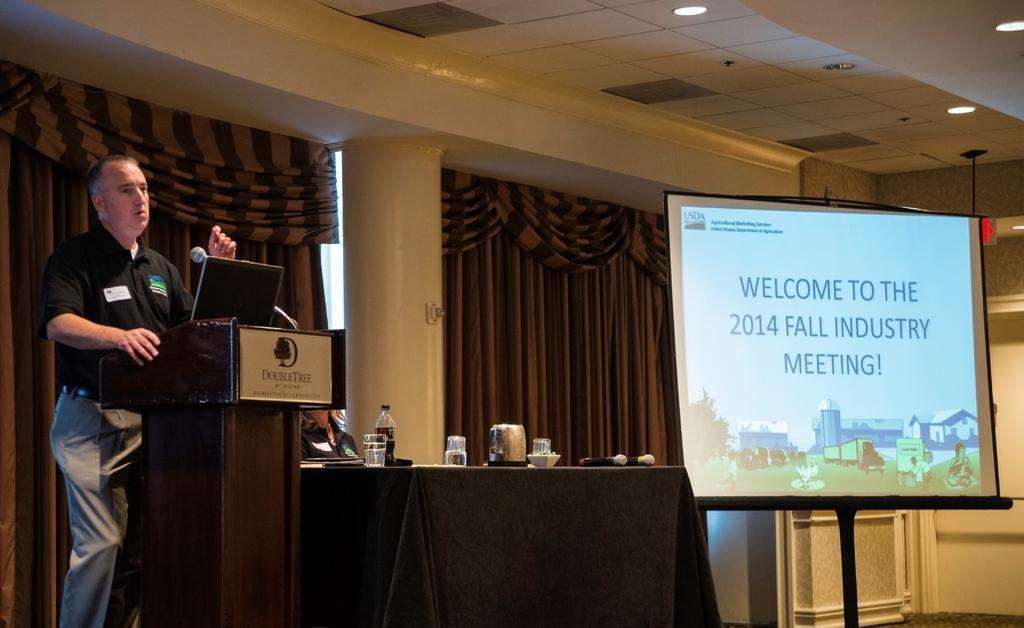How would you summarize this image in a sentence or two? In this image we can see a person is standing in front of a podium and talking, he is wearing black color t-shirt and grey pant. Beside him one black table is there. It is covered with black cloth, on table glass, bottle and mic is present. Behind it one lady is sitting. To the right side of the image we can see one screen, on screen some text is written. The roof, walls and pillars of the room is in white color. Background we can see curtains. 